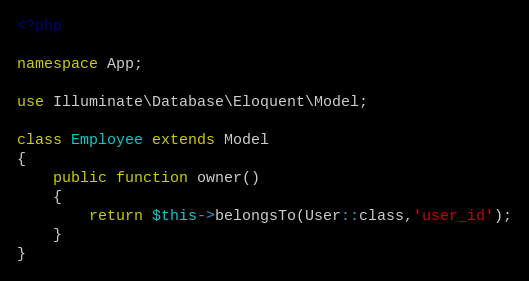Convert code to text. <code><loc_0><loc_0><loc_500><loc_500><_PHP_><?php

namespace App;

use Illuminate\Database\Eloquent\Model;

class Employee extends Model
{
    public function owner()
    {
        return $this->belongsTo(User::class,'user_id');
    }
}
</code> 